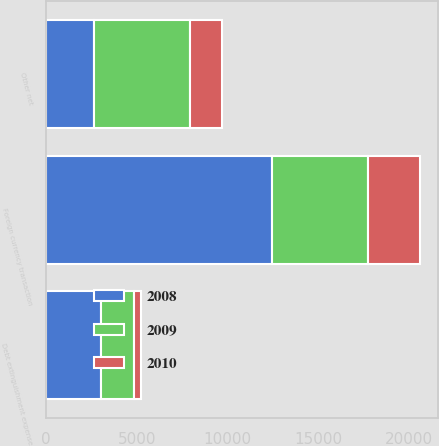Convert chart to OTSL. <chart><loc_0><loc_0><loc_500><loc_500><stacked_bar_chart><ecel><fcel>Foreign currency transaction<fcel>Debt extinguishment expense<fcel>Other net<nl><fcel>2010<fcel>2832<fcel>418<fcel>1728<nl><fcel>2008<fcel>12477<fcel>3031<fcel>2633<nl><fcel>2009<fcel>5305<fcel>1792<fcel>5325<nl></chart> 